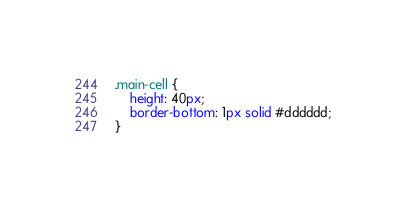Convert code to text. <code><loc_0><loc_0><loc_500><loc_500><_CSS_>.main-cell {
    height: 40px;
    border-bottom: 1px solid #dddddd;
}</code> 